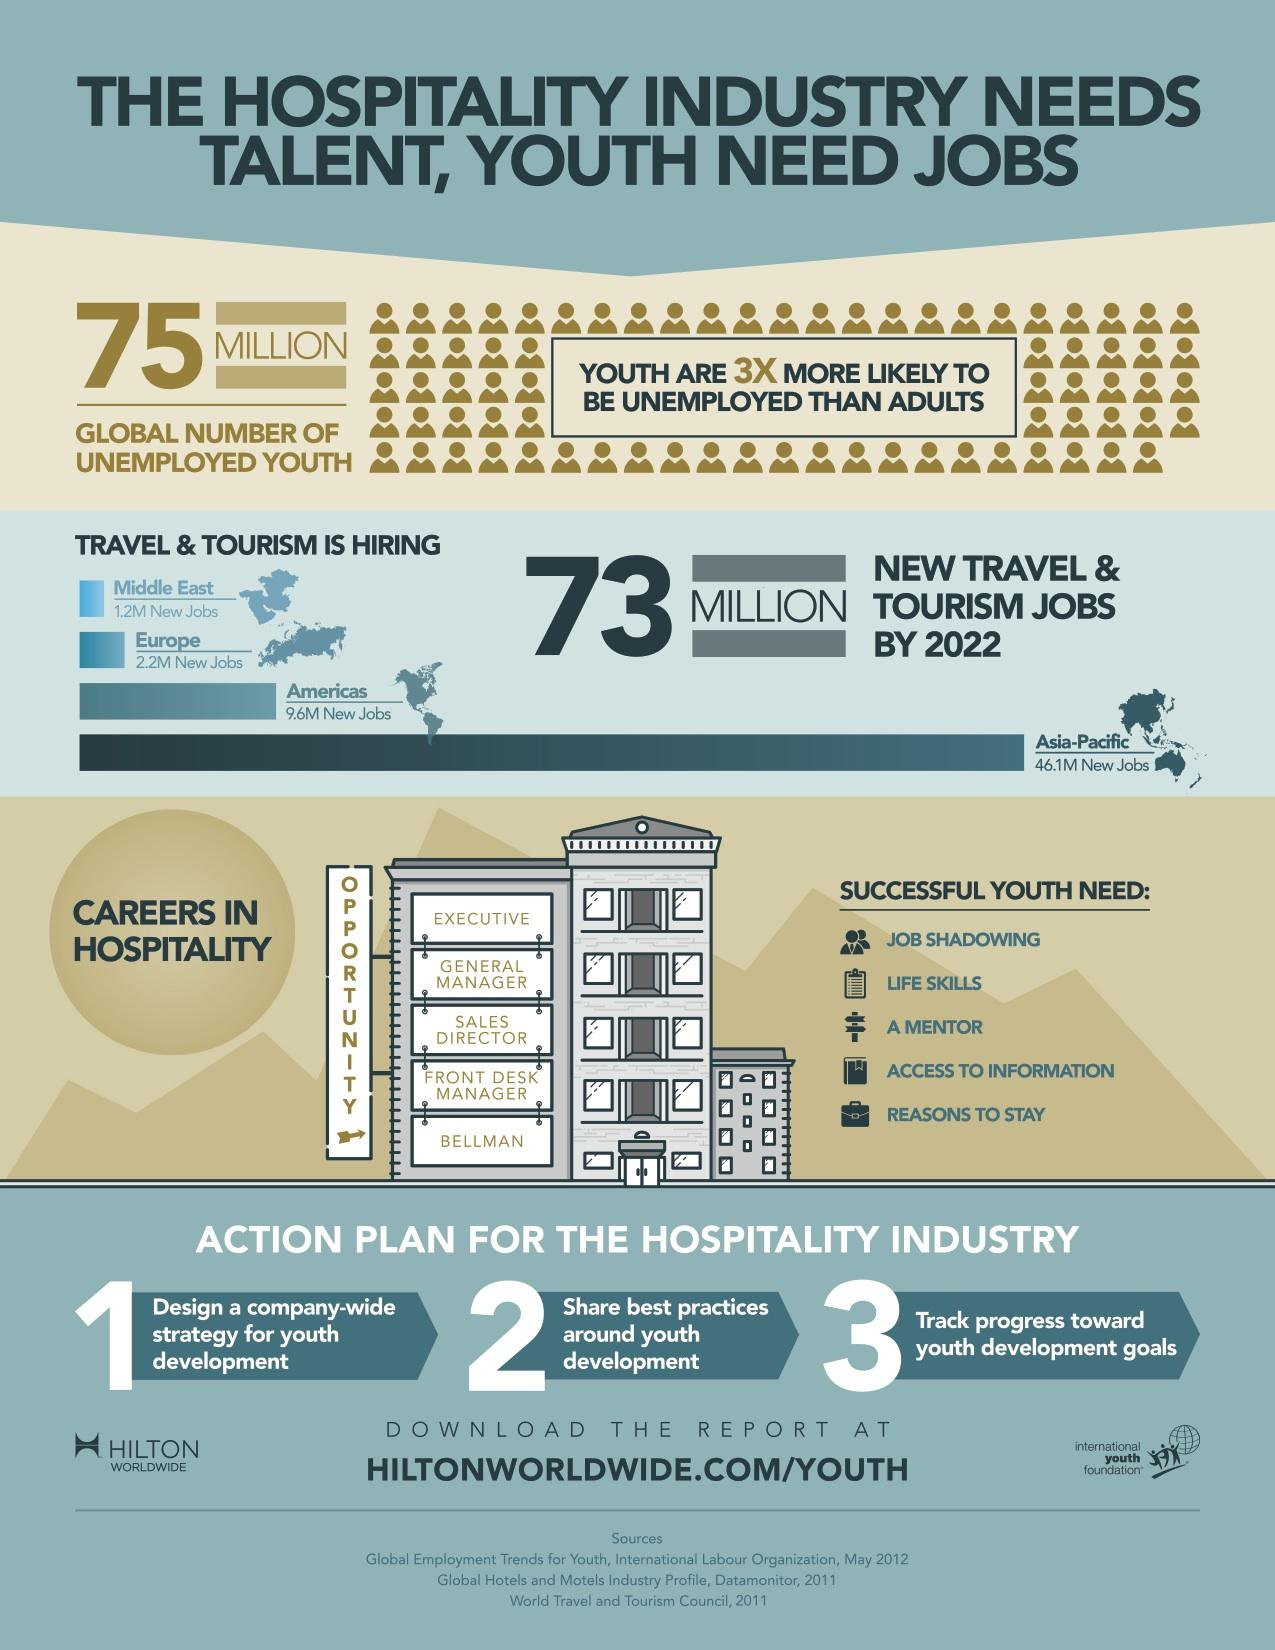Give some essential details in this illustration. There are an abundance of career opportunities available in the hospitality industry, with a reported 5 available. There are a total of 59.1 million new job opportunities available in the travel and tourism industry. 